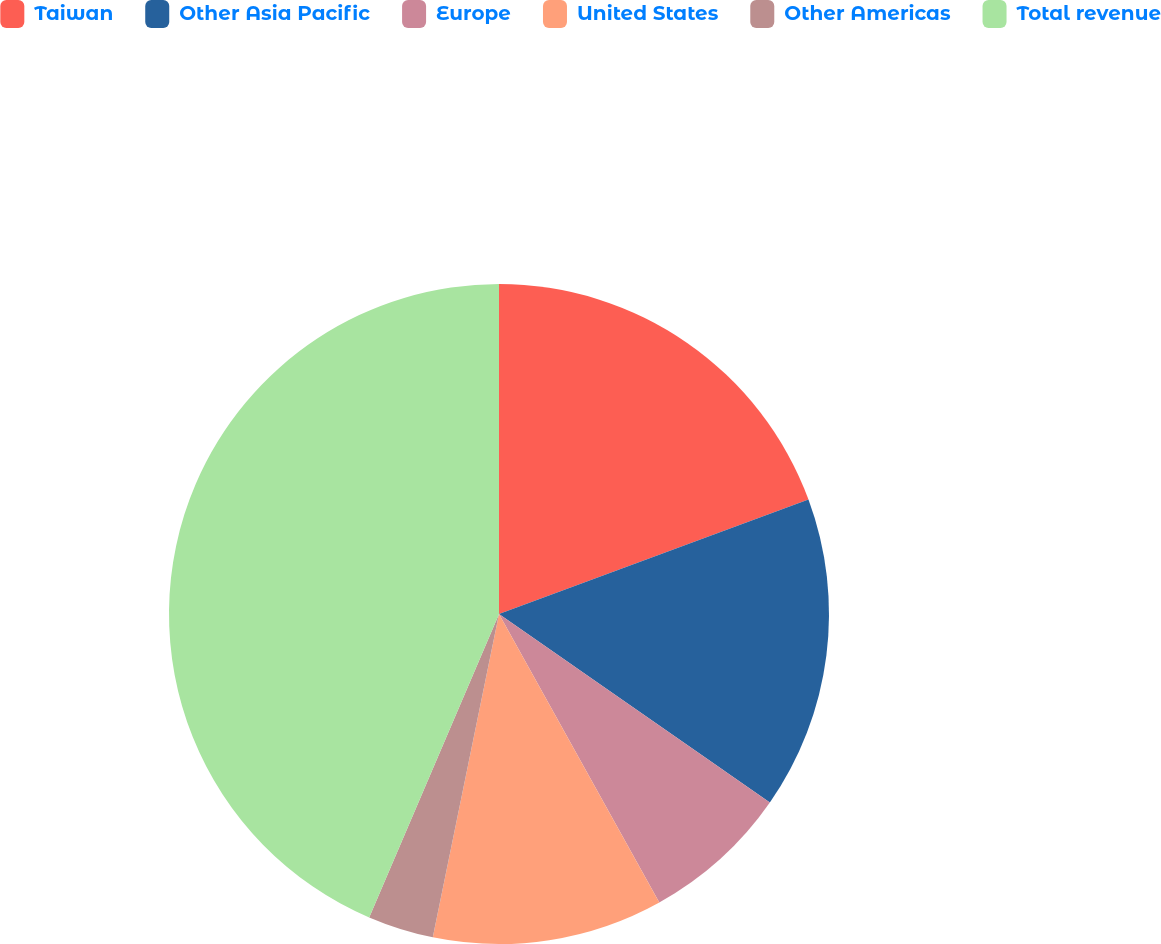Convert chart. <chart><loc_0><loc_0><loc_500><loc_500><pie_chart><fcel>Taiwan<fcel>Other Asia Pacific<fcel>Europe<fcel>United States<fcel>Other Americas<fcel>Total revenue<nl><fcel>19.36%<fcel>15.32%<fcel>7.25%<fcel>11.29%<fcel>3.22%<fcel>43.57%<nl></chart> 